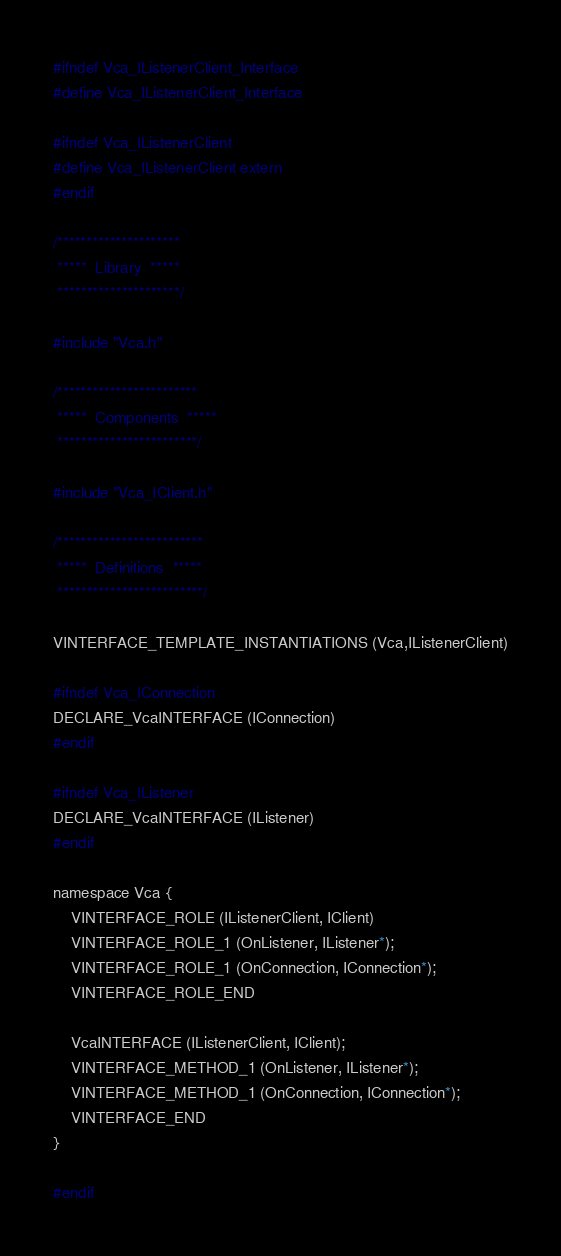<code> <loc_0><loc_0><loc_500><loc_500><_C_>#ifndef Vca_IListenerClient_Interface
#define Vca_IListenerClient_Interface

#ifndef Vca_IListenerClient
#define Vca_IListenerClient extern
#endif

/*********************
 *****  Library  *****
 *********************/

#include "Vca.h"

/************************
 *****  Components  *****
 ************************/

#include "Vca_IClient.h"

/*************************
 *****  Definitions  *****
 *************************/

VINTERFACE_TEMPLATE_INSTANTIATIONS (Vca,IListenerClient)

#ifndef Vca_IConnection
DECLARE_VcaINTERFACE (IConnection)
#endif

#ifndef Vca_IListener
DECLARE_VcaINTERFACE (IListener)
#endif

namespace Vca {
    VINTERFACE_ROLE (IListenerClient, IClient)
	VINTERFACE_ROLE_1 (OnListener, IListener*);
	VINTERFACE_ROLE_1 (OnConnection, IConnection*);
    VINTERFACE_ROLE_END

    VcaINTERFACE (IListenerClient, IClient);
	VINTERFACE_METHOD_1 (OnListener, IListener*);
	VINTERFACE_METHOD_1 (OnConnection, IConnection*);
    VINTERFACE_END
}

#endif
</code> 